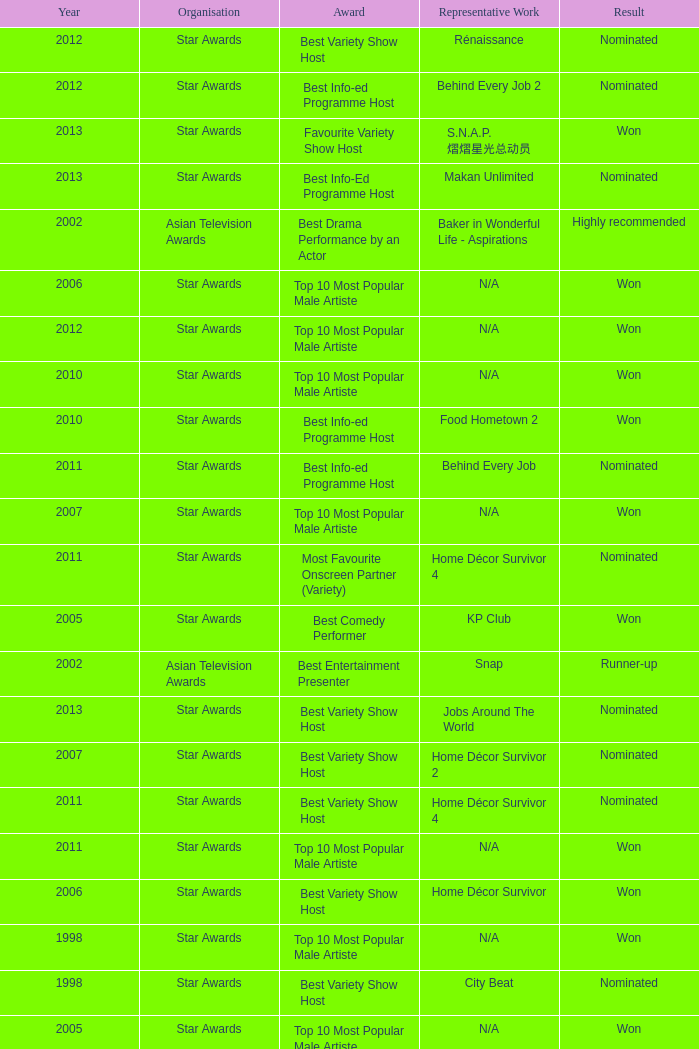What is the organisation in 2011 that was nominated and the award of best info-ed programme host? Star Awards. 